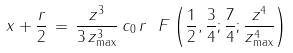Convert formula to latex. <formula><loc_0><loc_0><loc_500><loc_500>x + \frac { r } { 2 } \, = \, \frac { z ^ { 3 } } { 3 \, z _ { \max } ^ { 3 } } \, c _ { 0 } \, r \ F \left ( \frac { 1 } { 2 } , \frac { 3 } { 4 } ; \frac { 7 } { 4 } ; \frac { z ^ { 4 } } { z _ { \max } ^ { 4 } } \right )</formula> 